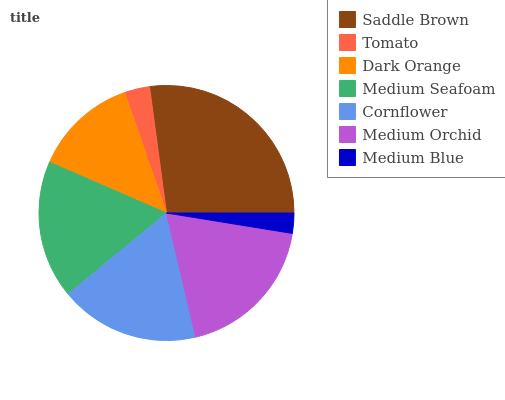Is Medium Blue the minimum?
Answer yes or no. Yes. Is Saddle Brown the maximum?
Answer yes or no. Yes. Is Tomato the minimum?
Answer yes or no. No. Is Tomato the maximum?
Answer yes or no. No. Is Saddle Brown greater than Tomato?
Answer yes or no. Yes. Is Tomato less than Saddle Brown?
Answer yes or no. Yes. Is Tomato greater than Saddle Brown?
Answer yes or no. No. Is Saddle Brown less than Tomato?
Answer yes or no. No. Is Medium Seafoam the high median?
Answer yes or no. Yes. Is Medium Seafoam the low median?
Answer yes or no. Yes. Is Cornflower the high median?
Answer yes or no. No. Is Saddle Brown the low median?
Answer yes or no. No. 